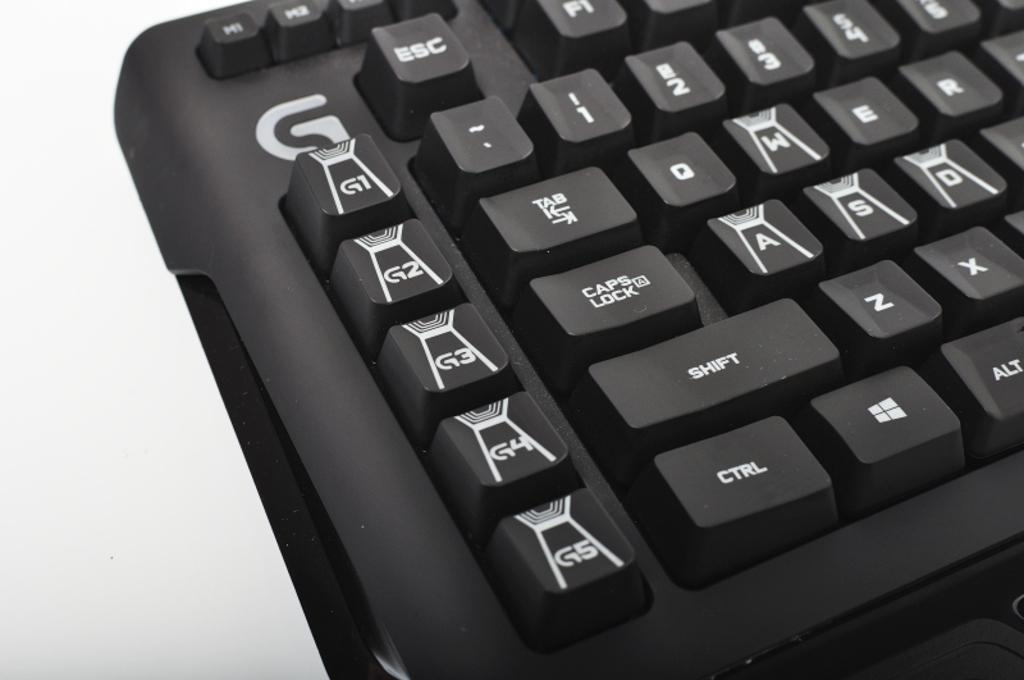<image>
Offer a succinct explanation of the picture presented. a keyboard with a column of keys on the left that say g1-g5 